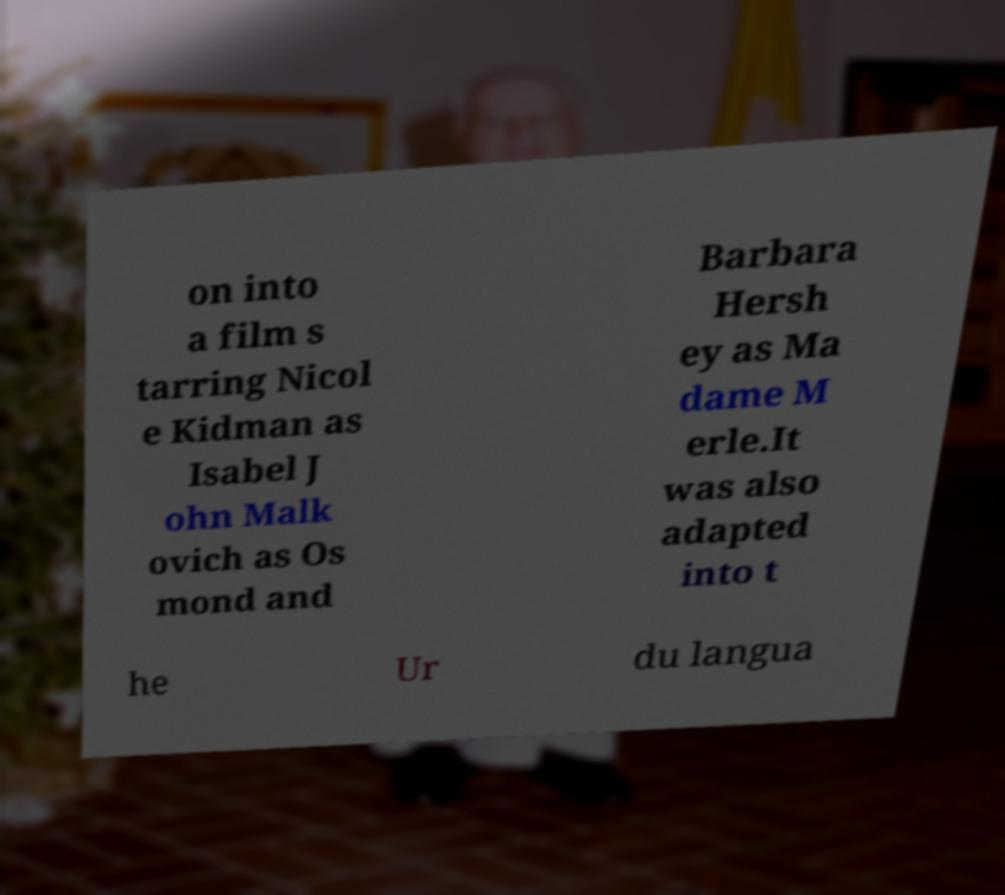Can you accurately transcribe the text from the provided image for me? on into a film s tarring Nicol e Kidman as Isabel J ohn Malk ovich as Os mond and Barbara Hersh ey as Ma dame M erle.It was also adapted into t he Ur du langua 